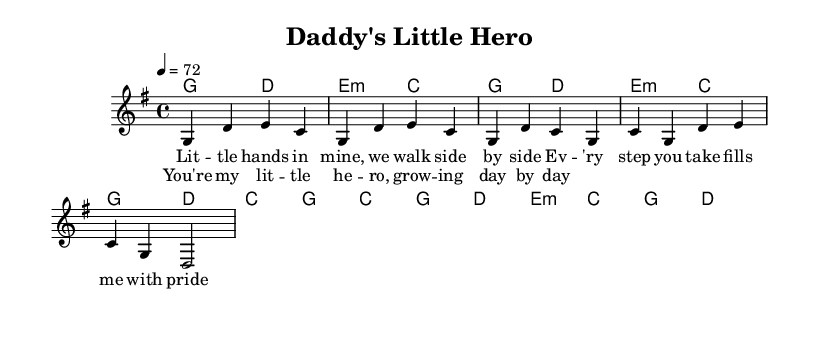What is the key signature of this music? The key signature is determined by looking at the number of sharps or flats present at the beginning of the staff. In this case, there are no sharps or flats indicated, which means the piece is in G major.
Answer: G major What is the time signature of this music? The time signature can be found near the beginning of the score, denoted by two numbers stacked vertically. Here, the time signature is specified as 4/4, indicating four beats per measure.
Answer: 4/4 What is the tempo marking for this piece? The tempo marking is listed above the staff, indicated as "4 = 72". This means the quarter note should be played at a speed of 72 beats per minute.
Answer: 72 How many lines are in the melody section? The melody section begins with a set of notes and is typically structured in two staves. Counting the lines in the melody (the treble clef), we see there are five lines representing the notes.
Answer: Five lines What chord is played at the beginning of the melody? The first chord is specified in the chord section, where it shows "g2 d2". The first chord is G major, as indicated by the "g" notation along with its duration.
Answer: G major What type of song structure is used in this piece? The song structure can be discerned from the labels of sections like "Verse" and "Chorus". The piece follows a common pop/rock structure, alternating between verses and choruses.
Answer: Verse-Chorus structure What theme does the song primarily focus on? The lyrics provided in the verse and chorus emphasize themes of paternal pride and admiration for the child, suggesting the song celebrates the bond between fathers and their children.
Answer: Father-child bond 